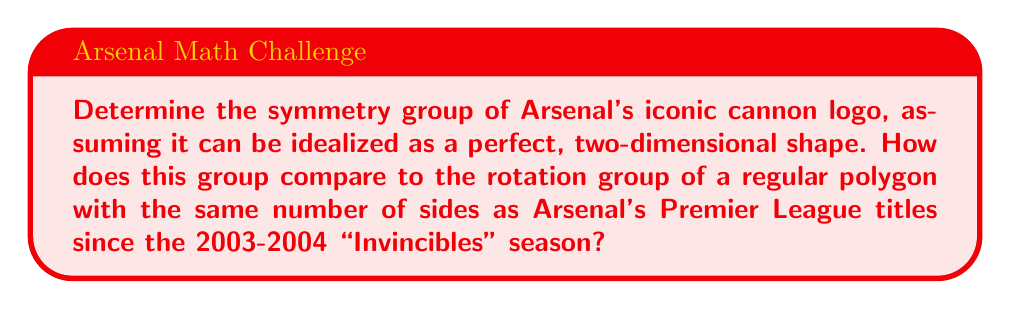Provide a solution to this math problem. Let's approach this step-by-step:

1) Arsenal's cannon logo can be idealized as a horizontally-oriented cannon shape. The key symmetries are:
   - Identity (do nothing)
   - Reflection across the horizontal axis

2) This forms a group with two elements, isomorphic to $\mathbb{Z}_2$, the cyclic group of order 2.

3) The group operation table is:
   $$
   \begin{array}{c|cc}
    \circ & e & r \\
    \hline
    e & e & r \\
    r & r & e
   \end{array}
   $$
   where $e$ is the identity and $r$ is the reflection.

4) Now, for the comparison:
   Arsenal has won 0 Premier League titles since the 2003-2004 "Invincibles" season.

5) The rotation group of a regular 0-gon (a point) is the trivial group $\{e\}$, which has only the identity element.

6) Therefore, the symmetry group of the cannon logo (order 2) is larger than the rotation group of a regular polygon with sides equal to Arsenal's post-Invincibles titles (order 1).

This comparison might resonate with an old-school fan's perspective on the club's recent performance compared to its glorious past.
Answer: The symmetry group of Arsenal's cannon logo is isomorphic to $\mathbb{Z}_2$, which has order 2. This is larger than the trivial group of order 1, which is the rotation group of a regular polygon with sides equal to Arsenal's Premier League titles since the 2003-2004 season. 